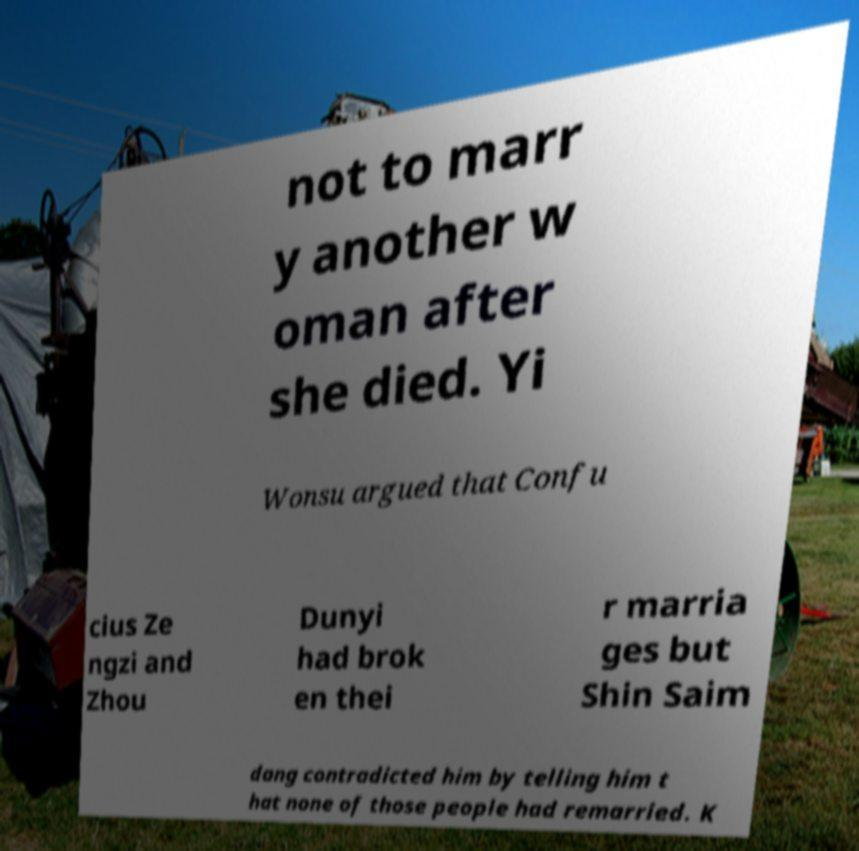Please identify and transcribe the text found in this image. not to marr y another w oman after she died. Yi Wonsu argued that Confu cius Ze ngzi and Zhou Dunyi had brok en thei r marria ges but Shin Saim dang contradicted him by telling him t hat none of those people had remarried. K 